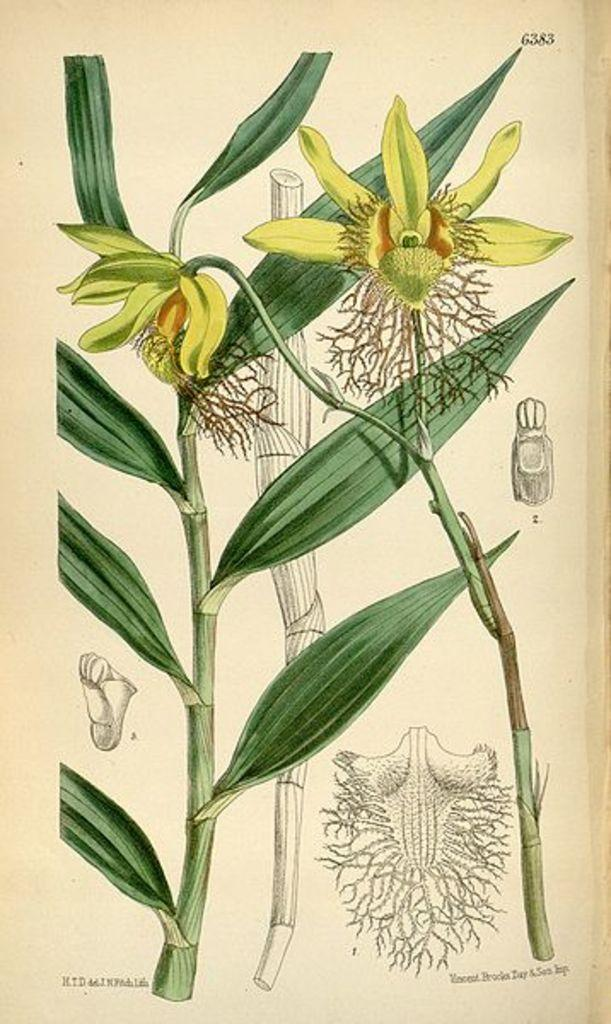What type of images can be seen on the paper in the image? There are pictures of plants, flowers, and roots in the image. What is the medium for these images? The images are on a paper. Is there any text accompanying the images on the paper? Yes, there is text on the paper. Can you describe the shoe that is visible in the image? There is no shoe present in the image; it features pictures of plants, flowers, and roots on a paper with accompanying text. 